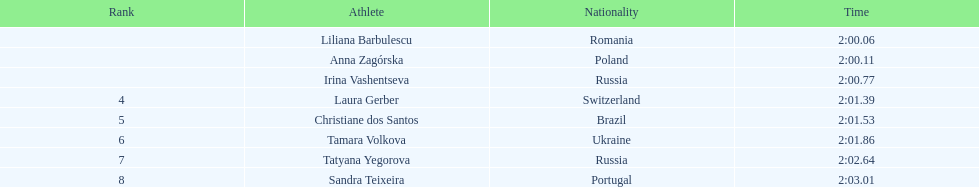How many athletes finished with their time beneath 2:01? 3. 